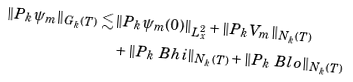<formula> <loc_0><loc_0><loc_500><loc_500>\| P _ { k } \psi _ { m } \| _ { G _ { k } ( T ) } \lesssim & \, \| P _ { k } \psi _ { m } ( 0 ) \| _ { L ^ { 2 } _ { x } } + \| P _ { k } V _ { m } \| _ { N _ { k } ( T ) } \\ & \, + \| P _ { k } \ B h i \| _ { N _ { k } ( T ) } + \| P _ { k } \ B l o \| _ { N _ { k } ( T ) }</formula> 